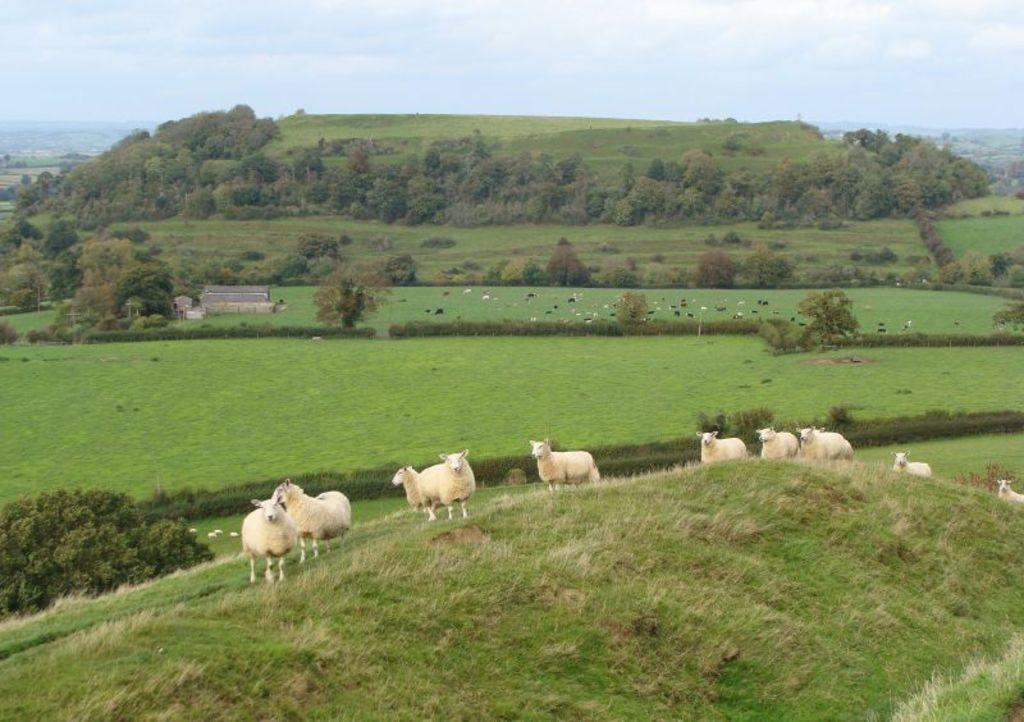What animals are standing in the image? There are sheep standing in the image. What type of vegetation is at the bottom of the image? There is grass at the bottom of the image. What can be seen in the background of the image? There are trees in the background of the image. What is visible in the sky in the image? The sky is visible in the image, and clouds are present. What type of liquid can be seen flowing through the cemetery in the image? There is no cemetery present in the image, and therefore no liquid flowing through it. Can you tell me how many geese are standing with the sheep in the image? There are no geese present in the image; only sheep are visible. 